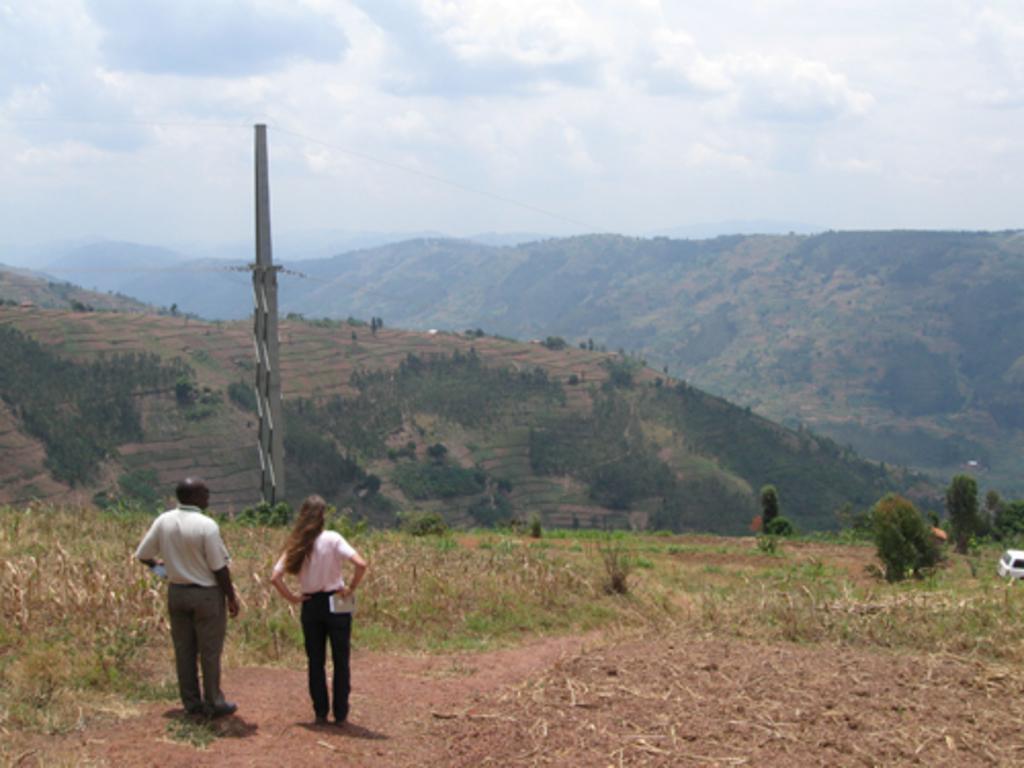Can you describe this image briefly? At the bottom of the image we can see man and woman on the ground. On the right side of the image we can see trees and vehicles. In the background there is a pole, hills, trees, sky and clouds. 